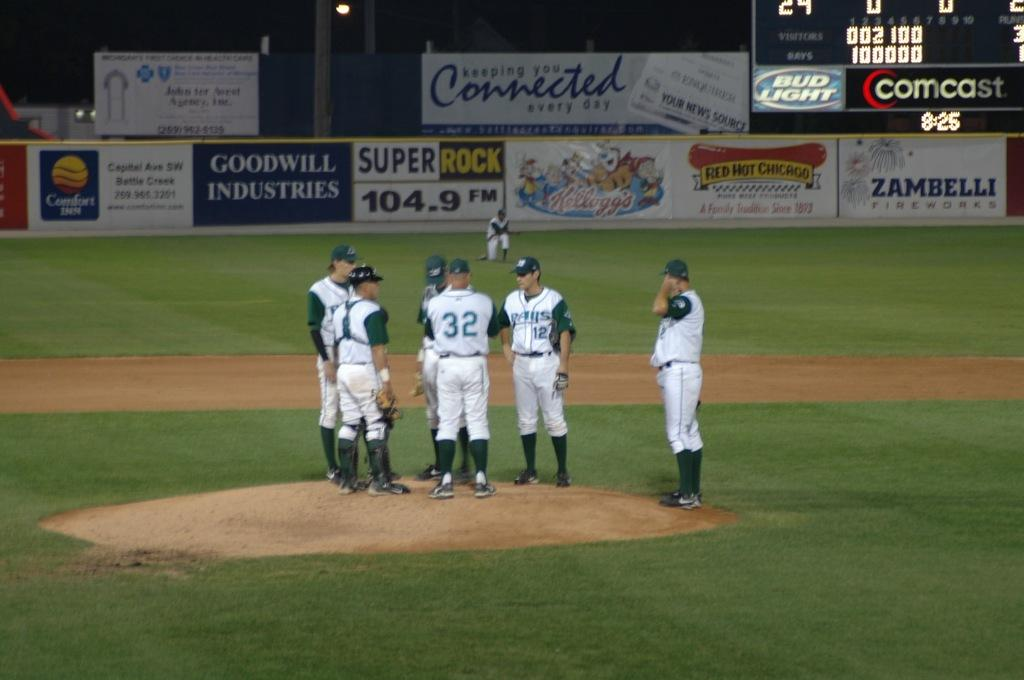<image>
Write a terse but informative summary of the picture. A baseball team gathers on the mound with a scoreboard in the background that has Bud Light and Comcast logos on it. 